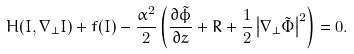Convert formula to latex. <formula><loc_0><loc_0><loc_500><loc_500>H ( I , \nabla _ { \perp } I ) + f ( I ) - \frac { \alpha ^ { 2 } } { 2 } \left ( \frac { \partial \tilde { \phi } } { \partial z } + R + \frac { 1 } { 2 } \left | \nabla _ { \perp } \tilde { \Phi } \right | ^ { 2 } \right ) = 0 .</formula> 